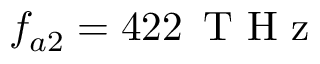<formula> <loc_0><loc_0><loc_500><loc_500>f _ { a 2 } = 4 2 2 \, T H z</formula> 